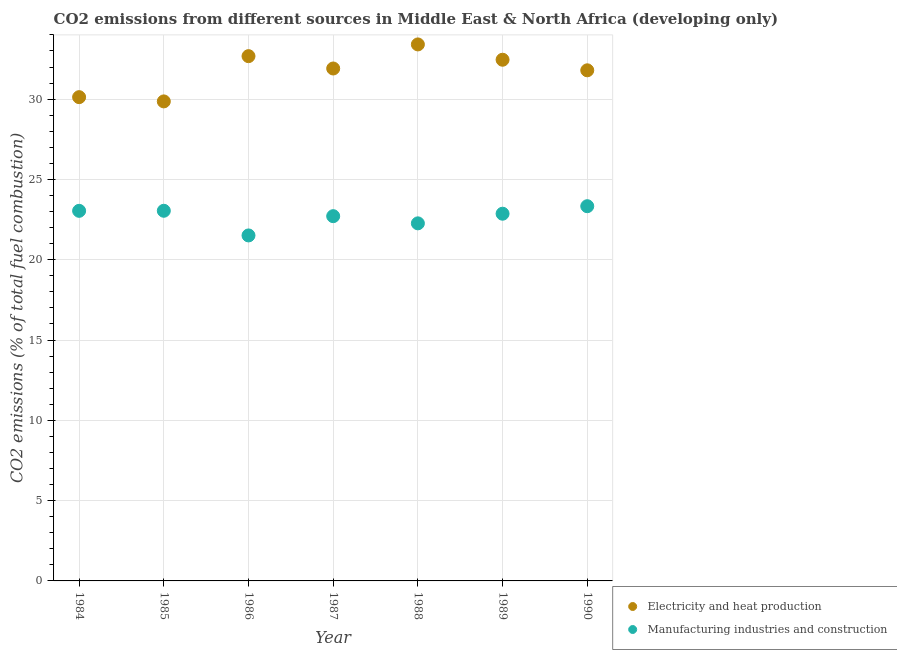What is the co2 emissions due to manufacturing industries in 1988?
Your answer should be very brief. 22.27. Across all years, what is the maximum co2 emissions due to electricity and heat production?
Your answer should be compact. 33.41. Across all years, what is the minimum co2 emissions due to manufacturing industries?
Offer a terse response. 21.51. In which year was the co2 emissions due to electricity and heat production maximum?
Your answer should be compact. 1988. In which year was the co2 emissions due to electricity and heat production minimum?
Offer a terse response. 1985. What is the total co2 emissions due to electricity and heat production in the graph?
Your answer should be compact. 222.23. What is the difference between the co2 emissions due to manufacturing industries in 1987 and that in 1989?
Provide a short and direct response. -0.15. What is the difference between the co2 emissions due to manufacturing industries in 1987 and the co2 emissions due to electricity and heat production in 1984?
Offer a terse response. -7.41. What is the average co2 emissions due to manufacturing industries per year?
Your response must be concise. 22.68. In the year 1990, what is the difference between the co2 emissions due to manufacturing industries and co2 emissions due to electricity and heat production?
Offer a terse response. -8.46. What is the ratio of the co2 emissions due to electricity and heat production in 1987 to that in 1989?
Your response must be concise. 0.98. What is the difference between the highest and the second highest co2 emissions due to electricity and heat production?
Your answer should be very brief. 0.73. What is the difference between the highest and the lowest co2 emissions due to electricity and heat production?
Your response must be concise. 3.55. In how many years, is the co2 emissions due to electricity and heat production greater than the average co2 emissions due to electricity and heat production taken over all years?
Offer a very short reply. 5. Does the graph contain grids?
Make the answer very short. Yes. How many legend labels are there?
Make the answer very short. 2. How are the legend labels stacked?
Provide a short and direct response. Vertical. What is the title of the graph?
Your response must be concise. CO2 emissions from different sources in Middle East & North Africa (developing only). Does "Food and tobacco" appear as one of the legend labels in the graph?
Offer a very short reply. No. What is the label or title of the X-axis?
Your answer should be very brief. Year. What is the label or title of the Y-axis?
Make the answer very short. CO2 emissions (% of total fuel combustion). What is the CO2 emissions (% of total fuel combustion) of Electricity and heat production in 1984?
Offer a very short reply. 30.12. What is the CO2 emissions (% of total fuel combustion) in Manufacturing industries and construction in 1984?
Offer a very short reply. 23.05. What is the CO2 emissions (% of total fuel combustion) in Electricity and heat production in 1985?
Your answer should be very brief. 29.86. What is the CO2 emissions (% of total fuel combustion) of Manufacturing industries and construction in 1985?
Your response must be concise. 23.05. What is the CO2 emissions (% of total fuel combustion) in Electricity and heat production in 1986?
Provide a succinct answer. 32.68. What is the CO2 emissions (% of total fuel combustion) of Manufacturing industries and construction in 1986?
Offer a very short reply. 21.51. What is the CO2 emissions (% of total fuel combustion) in Electricity and heat production in 1987?
Ensure brevity in your answer.  31.91. What is the CO2 emissions (% of total fuel combustion) of Manufacturing industries and construction in 1987?
Offer a very short reply. 22.71. What is the CO2 emissions (% of total fuel combustion) in Electricity and heat production in 1988?
Provide a succinct answer. 33.41. What is the CO2 emissions (% of total fuel combustion) in Manufacturing industries and construction in 1988?
Your answer should be very brief. 22.27. What is the CO2 emissions (% of total fuel combustion) of Electricity and heat production in 1989?
Your answer should be compact. 32.45. What is the CO2 emissions (% of total fuel combustion) in Manufacturing industries and construction in 1989?
Your response must be concise. 22.87. What is the CO2 emissions (% of total fuel combustion) in Electricity and heat production in 1990?
Give a very brief answer. 31.8. What is the CO2 emissions (% of total fuel combustion) of Manufacturing industries and construction in 1990?
Ensure brevity in your answer.  23.33. Across all years, what is the maximum CO2 emissions (% of total fuel combustion) of Electricity and heat production?
Provide a succinct answer. 33.41. Across all years, what is the maximum CO2 emissions (% of total fuel combustion) of Manufacturing industries and construction?
Provide a short and direct response. 23.33. Across all years, what is the minimum CO2 emissions (% of total fuel combustion) in Electricity and heat production?
Provide a short and direct response. 29.86. Across all years, what is the minimum CO2 emissions (% of total fuel combustion) in Manufacturing industries and construction?
Your response must be concise. 21.51. What is the total CO2 emissions (% of total fuel combustion) of Electricity and heat production in the graph?
Keep it short and to the point. 222.23. What is the total CO2 emissions (% of total fuel combustion) of Manufacturing industries and construction in the graph?
Give a very brief answer. 158.79. What is the difference between the CO2 emissions (% of total fuel combustion) in Electricity and heat production in 1984 and that in 1985?
Make the answer very short. 0.27. What is the difference between the CO2 emissions (% of total fuel combustion) in Manufacturing industries and construction in 1984 and that in 1985?
Your response must be concise. -0. What is the difference between the CO2 emissions (% of total fuel combustion) of Electricity and heat production in 1984 and that in 1986?
Your response must be concise. -2.55. What is the difference between the CO2 emissions (% of total fuel combustion) of Manufacturing industries and construction in 1984 and that in 1986?
Your response must be concise. 1.53. What is the difference between the CO2 emissions (% of total fuel combustion) in Electricity and heat production in 1984 and that in 1987?
Provide a short and direct response. -1.78. What is the difference between the CO2 emissions (% of total fuel combustion) in Manufacturing industries and construction in 1984 and that in 1987?
Provide a succinct answer. 0.33. What is the difference between the CO2 emissions (% of total fuel combustion) of Electricity and heat production in 1984 and that in 1988?
Give a very brief answer. -3.28. What is the difference between the CO2 emissions (% of total fuel combustion) in Manufacturing industries and construction in 1984 and that in 1988?
Provide a short and direct response. 0.78. What is the difference between the CO2 emissions (% of total fuel combustion) of Electricity and heat production in 1984 and that in 1989?
Ensure brevity in your answer.  -2.33. What is the difference between the CO2 emissions (% of total fuel combustion) of Manufacturing industries and construction in 1984 and that in 1989?
Make the answer very short. 0.18. What is the difference between the CO2 emissions (% of total fuel combustion) in Electricity and heat production in 1984 and that in 1990?
Offer a very short reply. -1.67. What is the difference between the CO2 emissions (% of total fuel combustion) of Manufacturing industries and construction in 1984 and that in 1990?
Offer a terse response. -0.29. What is the difference between the CO2 emissions (% of total fuel combustion) in Electricity and heat production in 1985 and that in 1986?
Your answer should be very brief. -2.82. What is the difference between the CO2 emissions (% of total fuel combustion) in Manufacturing industries and construction in 1985 and that in 1986?
Provide a short and direct response. 1.54. What is the difference between the CO2 emissions (% of total fuel combustion) in Electricity and heat production in 1985 and that in 1987?
Your answer should be very brief. -2.05. What is the difference between the CO2 emissions (% of total fuel combustion) of Manufacturing industries and construction in 1985 and that in 1987?
Provide a succinct answer. 0.34. What is the difference between the CO2 emissions (% of total fuel combustion) in Electricity and heat production in 1985 and that in 1988?
Your response must be concise. -3.55. What is the difference between the CO2 emissions (% of total fuel combustion) in Manufacturing industries and construction in 1985 and that in 1988?
Provide a short and direct response. 0.78. What is the difference between the CO2 emissions (% of total fuel combustion) of Electricity and heat production in 1985 and that in 1989?
Ensure brevity in your answer.  -2.59. What is the difference between the CO2 emissions (% of total fuel combustion) in Manufacturing industries and construction in 1985 and that in 1989?
Make the answer very short. 0.18. What is the difference between the CO2 emissions (% of total fuel combustion) in Electricity and heat production in 1985 and that in 1990?
Ensure brevity in your answer.  -1.94. What is the difference between the CO2 emissions (% of total fuel combustion) of Manufacturing industries and construction in 1985 and that in 1990?
Keep it short and to the point. -0.28. What is the difference between the CO2 emissions (% of total fuel combustion) of Electricity and heat production in 1986 and that in 1987?
Your answer should be compact. 0.77. What is the difference between the CO2 emissions (% of total fuel combustion) of Manufacturing industries and construction in 1986 and that in 1987?
Make the answer very short. -1.2. What is the difference between the CO2 emissions (% of total fuel combustion) in Electricity and heat production in 1986 and that in 1988?
Offer a terse response. -0.73. What is the difference between the CO2 emissions (% of total fuel combustion) of Manufacturing industries and construction in 1986 and that in 1988?
Provide a short and direct response. -0.75. What is the difference between the CO2 emissions (% of total fuel combustion) of Electricity and heat production in 1986 and that in 1989?
Offer a terse response. 0.22. What is the difference between the CO2 emissions (% of total fuel combustion) of Manufacturing industries and construction in 1986 and that in 1989?
Keep it short and to the point. -1.35. What is the difference between the CO2 emissions (% of total fuel combustion) of Electricity and heat production in 1986 and that in 1990?
Provide a succinct answer. 0.88. What is the difference between the CO2 emissions (% of total fuel combustion) in Manufacturing industries and construction in 1986 and that in 1990?
Your response must be concise. -1.82. What is the difference between the CO2 emissions (% of total fuel combustion) in Electricity and heat production in 1987 and that in 1988?
Offer a very short reply. -1.5. What is the difference between the CO2 emissions (% of total fuel combustion) of Manufacturing industries and construction in 1987 and that in 1988?
Give a very brief answer. 0.45. What is the difference between the CO2 emissions (% of total fuel combustion) of Electricity and heat production in 1987 and that in 1989?
Your answer should be compact. -0.55. What is the difference between the CO2 emissions (% of total fuel combustion) in Manufacturing industries and construction in 1987 and that in 1989?
Provide a short and direct response. -0.15. What is the difference between the CO2 emissions (% of total fuel combustion) of Electricity and heat production in 1987 and that in 1990?
Your answer should be compact. 0.11. What is the difference between the CO2 emissions (% of total fuel combustion) of Manufacturing industries and construction in 1987 and that in 1990?
Keep it short and to the point. -0.62. What is the difference between the CO2 emissions (% of total fuel combustion) in Electricity and heat production in 1988 and that in 1989?
Ensure brevity in your answer.  0.95. What is the difference between the CO2 emissions (% of total fuel combustion) in Manufacturing industries and construction in 1988 and that in 1989?
Offer a terse response. -0.6. What is the difference between the CO2 emissions (% of total fuel combustion) of Electricity and heat production in 1988 and that in 1990?
Provide a short and direct response. 1.61. What is the difference between the CO2 emissions (% of total fuel combustion) in Manufacturing industries and construction in 1988 and that in 1990?
Ensure brevity in your answer.  -1.07. What is the difference between the CO2 emissions (% of total fuel combustion) of Electricity and heat production in 1989 and that in 1990?
Your response must be concise. 0.66. What is the difference between the CO2 emissions (% of total fuel combustion) of Manufacturing industries and construction in 1989 and that in 1990?
Offer a terse response. -0.47. What is the difference between the CO2 emissions (% of total fuel combustion) in Electricity and heat production in 1984 and the CO2 emissions (% of total fuel combustion) in Manufacturing industries and construction in 1985?
Your answer should be compact. 7.08. What is the difference between the CO2 emissions (% of total fuel combustion) in Electricity and heat production in 1984 and the CO2 emissions (% of total fuel combustion) in Manufacturing industries and construction in 1986?
Keep it short and to the point. 8.61. What is the difference between the CO2 emissions (% of total fuel combustion) of Electricity and heat production in 1984 and the CO2 emissions (% of total fuel combustion) of Manufacturing industries and construction in 1987?
Make the answer very short. 7.41. What is the difference between the CO2 emissions (% of total fuel combustion) in Electricity and heat production in 1984 and the CO2 emissions (% of total fuel combustion) in Manufacturing industries and construction in 1988?
Offer a terse response. 7.86. What is the difference between the CO2 emissions (% of total fuel combustion) of Electricity and heat production in 1984 and the CO2 emissions (% of total fuel combustion) of Manufacturing industries and construction in 1989?
Offer a terse response. 7.26. What is the difference between the CO2 emissions (% of total fuel combustion) in Electricity and heat production in 1984 and the CO2 emissions (% of total fuel combustion) in Manufacturing industries and construction in 1990?
Your answer should be very brief. 6.79. What is the difference between the CO2 emissions (% of total fuel combustion) of Electricity and heat production in 1985 and the CO2 emissions (% of total fuel combustion) of Manufacturing industries and construction in 1986?
Offer a very short reply. 8.35. What is the difference between the CO2 emissions (% of total fuel combustion) in Electricity and heat production in 1985 and the CO2 emissions (% of total fuel combustion) in Manufacturing industries and construction in 1987?
Ensure brevity in your answer.  7.15. What is the difference between the CO2 emissions (% of total fuel combustion) of Electricity and heat production in 1985 and the CO2 emissions (% of total fuel combustion) of Manufacturing industries and construction in 1988?
Offer a terse response. 7.59. What is the difference between the CO2 emissions (% of total fuel combustion) of Electricity and heat production in 1985 and the CO2 emissions (% of total fuel combustion) of Manufacturing industries and construction in 1989?
Keep it short and to the point. 6.99. What is the difference between the CO2 emissions (% of total fuel combustion) in Electricity and heat production in 1985 and the CO2 emissions (% of total fuel combustion) in Manufacturing industries and construction in 1990?
Give a very brief answer. 6.53. What is the difference between the CO2 emissions (% of total fuel combustion) in Electricity and heat production in 1986 and the CO2 emissions (% of total fuel combustion) in Manufacturing industries and construction in 1987?
Provide a succinct answer. 9.96. What is the difference between the CO2 emissions (% of total fuel combustion) of Electricity and heat production in 1986 and the CO2 emissions (% of total fuel combustion) of Manufacturing industries and construction in 1988?
Provide a succinct answer. 10.41. What is the difference between the CO2 emissions (% of total fuel combustion) in Electricity and heat production in 1986 and the CO2 emissions (% of total fuel combustion) in Manufacturing industries and construction in 1989?
Provide a succinct answer. 9.81. What is the difference between the CO2 emissions (% of total fuel combustion) of Electricity and heat production in 1986 and the CO2 emissions (% of total fuel combustion) of Manufacturing industries and construction in 1990?
Provide a short and direct response. 9.34. What is the difference between the CO2 emissions (% of total fuel combustion) of Electricity and heat production in 1987 and the CO2 emissions (% of total fuel combustion) of Manufacturing industries and construction in 1988?
Offer a very short reply. 9.64. What is the difference between the CO2 emissions (% of total fuel combustion) of Electricity and heat production in 1987 and the CO2 emissions (% of total fuel combustion) of Manufacturing industries and construction in 1989?
Your response must be concise. 9.04. What is the difference between the CO2 emissions (% of total fuel combustion) in Electricity and heat production in 1987 and the CO2 emissions (% of total fuel combustion) in Manufacturing industries and construction in 1990?
Ensure brevity in your answer.  8.57. What is the difference between the CO2 emissions (% of total fuel combustion) of Electricity and heat production in 1988 and the CO2 emissions (% of total fuel combustion) of Manufacturing industries and construction in 1989?
Your response must be concise. 10.54. What is the difference between the CO2 emissions (% of total fuel combustion) in Electricity and heat production in 1988 and the CO2 emissions (% of total fuel combustion) in Manufacturing industries and construction in 1990?
Offer a very short reply. 10.07. What is the difference between the CO2 emissions (% of total fuel combustion) in Electricity and heat production in 1989 and the CO2 emissions (% of total fuel combustion) in Manufacturing industries and construction in 1990?
Make the answer very short. 9.12. What is the average CO2 emissions (% of total fuel combustion) of Electricity and heat production per year?
Keep it short and to the point. 31.75. What is the average CO2 emissions (% of total fuel combustion) of Manufacturing industries and construction per year?
Keep it short and to the point. 22.68. In the year 1984, what is the difference between the CO2 emissions (% of total fuel combustion) in Electricity and heat production and CO2 emissions (% of total fuel combustion) in Manufacturing industries and construction?
Provide a succinct answer. 7.08. In the year 1985, what is the difference between the CO2 emissions (% of total fuel combustion) in Electricity and heat production and CO2 emissions (% of total fuel combustion) in Manufacturing industries and construction?
Give a very brief answer. 6.81. In the year 1986, what is the difference between the CO2 emissions (% of total fuel combustion) in Electricity and heat production and CO2 emissions (% of total fuel combustion) in Manufacturing industries and construction?
Make the answer very short. 11.16. In the year 1987, what is the difference between the CO2 emissions (% of total fuel combustion) of Electricity and heat production and CO2 emissions (% of total fuel combustion) of Manufacturing industries and construction?
Your answer should be very brief. 9.2. In the year 1988, what is the difference between the CO2 emissions (% of total fuel combustion) in Electricity and heat production and CO2 emissions (% of total fuel combustion) in Manufacturing industries and construction?
Your answer should be compact. 11.14. In the year 1989, what is the difference between the CO2 emissions (% of total fuel combustion) in Electricity and heat production and CO2 emissions (% of total fuel combustion) in Manufacturing industries and construction?
Give a very brief answer. 9.59. In the year 1990, what is the difference between the CO2 emissions (% of total fuel combustion) in Electricity and heat production and CO2 emissions (% of total fuel combustion) in Manufacturing industries and construction?
Your answer should be very brief. 8.46. What is the ratio of the CO2 emissions (% of total fuel combustion) of Electricity and heat production in 1984 to that in 1985?
Give a very brief answer. 1.01. What is the ratio of the CO2 emissions (% of total fuel combustion) in Electricity and heat production in 1984 to that in 1986?
Ensure brevity in your answer.  0.92. What is the ratio of the CO2 emissions (% of total fuel combustion) of Manufacturing industries and construction in 1984 to that in 1986?
Provide a succinct answer. 1.07. What is the ratio of the CO2 emissions (% of total fuel combustion) in Electricity and heat production in 1984 to that in 1987?
Ensure brevity in your answer.  0.94. What is the ratio of the CO2 emissions (% of total fuel combustion) of Manufacturing industries and construction in 1984 to that in 1987?
Keep it short and to the point. 1.01. What is the ratio of the CO2 emissions (% of total fuel combustion) of Electricity and heat production in 1984 to that in 1988?
Ensure brevity in your answer.  0.9. What is the ratio of the CO2 emissions (% of total fuel combustion) in Manufacturing industries and construction in 1984 to that in 1988?
Make the answer very short. 1.03. What is the ratio of the CO2 emissions (% of total fuel combustion) in Electricity and heat production in 1984 to that in 1989?
Provide a succinct answer. 0.93. What is the ratio of the CO2 emissions (% of total fuel combustion) of Manufacturing industries and construction in 1984 to that in 1989?
Your answer should be very brief. 1.01. What is the ratio of the CO2 emissions (% of total fuel combustion) in Electricity and heat production in 1985 to that in 1986?
Your response must be concise. 0.91. What is the ratio of the CO2 emissions (% of total fuel combustion) of Manufacturing industries and construction in 1985 to that in 1986?
Your response must be concise. 1.07. What is the ratio of the CO2 emissions (% of total fuel combustion) in Electricity and heat production in 1985 to that in 1987?
Keep it short and to the point. 0.94. What is the ratio of the CO2 emissions (% of total fuel combustion) of Manufacturing industries and construction in 1985 to that in 1987?
Ensure brevity in your answer.  1.01. What is the ratio of the CO2 emissions (% of total fuel combustion) of Electricity and heat production in 1985 to that in 1988?
Offer a very short reply. 0.89. What is the ratio of the CO2 emissions (% of total fuel combustion) of Manufacturing industries and construction in 1985 to that in 1988?
Provide a short and direct response. 1.04. What is the ratio of the CO2 emissions (% of total fuel combustion) of Electricity and heat production in 1985 to that in 1989?
Offer a terse response. 0.92. What is the ratio of the CO2 emissions (% of total fuel combustion) in Electricity and heat production in 1985 to that in 1990?
Offer a terse response. 0.94. What is the ratio of the CO2 emissions (% of total fuel combustion) in Manufacturing industries and construction in 1985 to that in 1990?
Give a very brief answer. 0.99. What is the ratio of the CO2 emissions (% of total fuel combustion) of Electricity and heat production in 1986 to that in 1987?
Give a very brief answer. 1.02. What is the ratio of the CO2 emissions (% of total fuel combustion) of Manufacturing industries and construction in 1986 to that in 1987?
Your answer should be very brief. 0.95. What is the ratio of the CO2 emissions (% of total fuel combustion) of Electricity and heat production in 1986 to that in 1988?
Provide a succinct answer. 0.98. What is the ratio of the CO2 emissions (% of total fuel combustion) in Manufacturing industries and construction in 1986 to that in 1988?
Your answer should be very brief. 0.97. What is the ratio of the CO2 emissions (% of total fuel combustion) in Electricity and heat production in 1986 to that in 1989?
Offer a terse response. 1.01. What is the ratio of the CO2 emissions (% of total fuel combustion) of Manufacturing industries and construction in 1986 to that in 1989?
Your answer should be compact. 0.94. What is the ratio of the CO2 emissions (% of total fuel combustion) in Electricity and heat production in 1986 to that in 1990?
Your response must be concise. 1.03. What is the ratio of the CO2 emissions (% of total fuel combustion) in Manufacturing industries and construction in 1986 to that in 1990?
Offer a very short reply. 0.92. What is the ratio of the CO2 emissions (% of total fuel combustion) in Electricity and heat production in 1987 to that in 1988?
Offer a terse response. 0.96. What is the ratio of the CO2 emissions (% of total fuel combustion) in Manufacturing industries and construction in 1987 to that in 1988?
Your answer should be very brief. 1.02. What is the ratio of the CO2 emissions (% of total fuel combustion) of Electricity and heat production in 1987 to that in 1989?
Provide a succinct answer. 0.98. What is the ratio of the CO2 emissions (% of total fuel combustion) in Electricity and heat production in 1987 to that in 1990?
Keep it short and to the point. 1. What is the ratio of the CO2 emissions (% of total fuel combustion) in Manufacturing industries and construction in 1987 to that in 1990?
Give a very brief answer. 0.97. What is the ratio of the CO2 emissions (% of total fuel combustion) of Electricity and heat production in 1988 to that in 1989?
Your response must be concise. 1.03. What is the ratio of the CO2 emissions (% of total fuel combustion) of Manufacturing industries and construction in 1988 to that in 1989?
Your response must be concise. 0.97. What is the ratio of the CO2 emissions (% of total fuel combustion) of Electricity and heat production in 1988 to that in 1990?
Your answer should be very brief. 1.05. What is the ratio of the CO2 emissions (% of total fuel combustion) of Manufacturing industries and construction in 1988 to that in 1990?
Offer a terse response. 0.95. What is the ratio of the CO2 emissions (% of total fuel combustion) of Electricity and heat production in 1989 to that in 1990?
Your answer should be compact. 1.02. What is the ratio of the CO2 emissions (% of total fuel combustion) of Manufacturing industries and construction in 1989 to that in 1990?
Offer a very short reply. 0.98. What is the difference between the highest and the second highest CO2 emissions (% of total fuel combustion) in Electricity and heat production?
Provide a short and direct response. 0.73. What is the difference between the highest and the second highest CO2 emissions (% of total fuel combustion) of Manufacturing industries and construction?
Keep it short and to the point. 0.28. What is the difference between the highest and the lowest CO2 emissions (% of total fuel combustion) of Electricity and heat production?
Offer a terse response. 3.55. What is the difference between the highest and the lowest CO2 emissions (% of total fuel combustion) of Manufacturing industries and construction?
Provide a succinct answer. 1.82. 